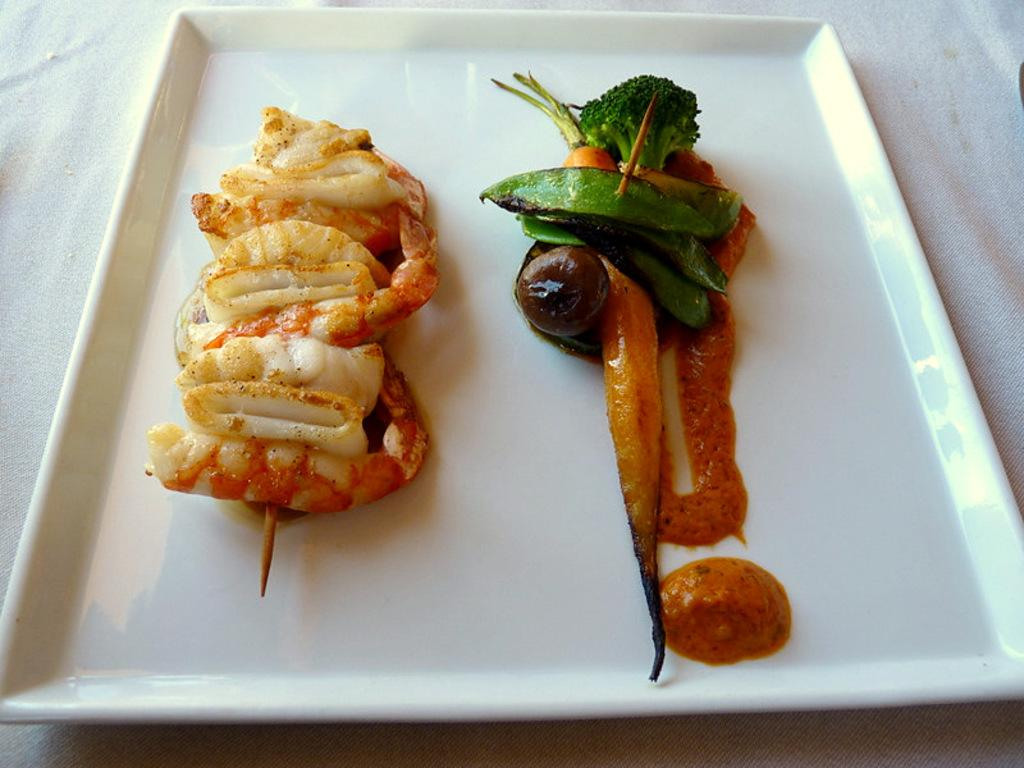What is present on the plate in the image? There is food in a plate in the image. How many sticks are being used in the activity depicted in the image? There is no activity involving sticks present in the image; it only shows a plate of food. 